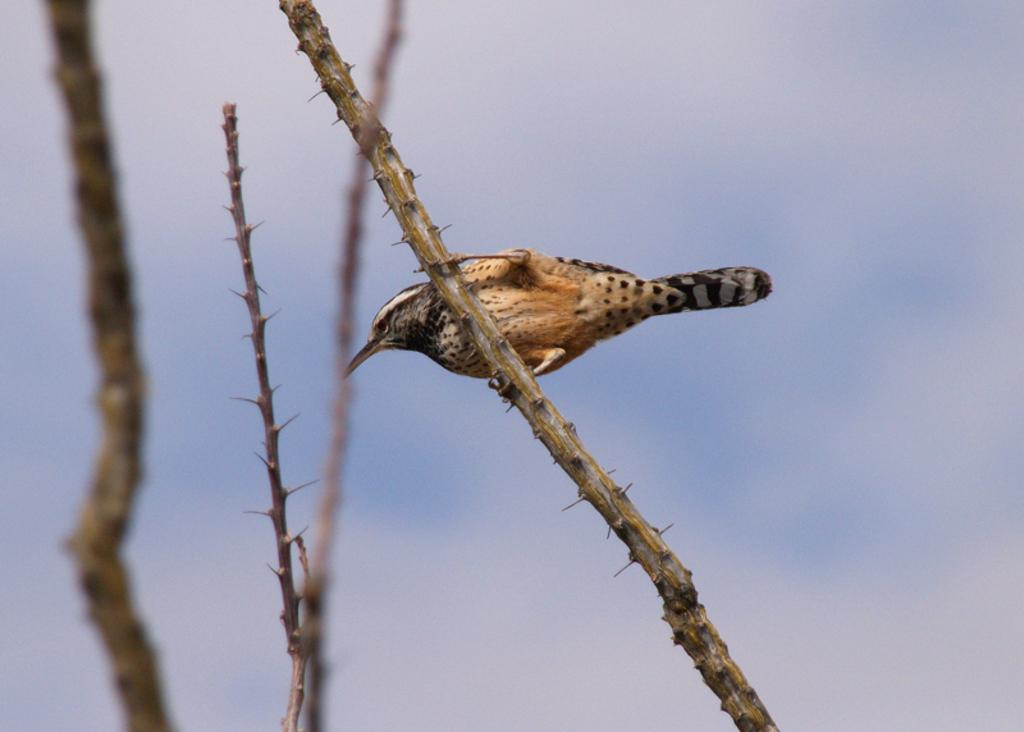What is the main subject of the image? There is a bird standing on a plant in the image. Can you describe the background of the image? The background of the image is blurry. What type of ice can be seen melting on the bird's wings in the image? There is no ice present in the image, and the bird's wings are not shown to be melting. 